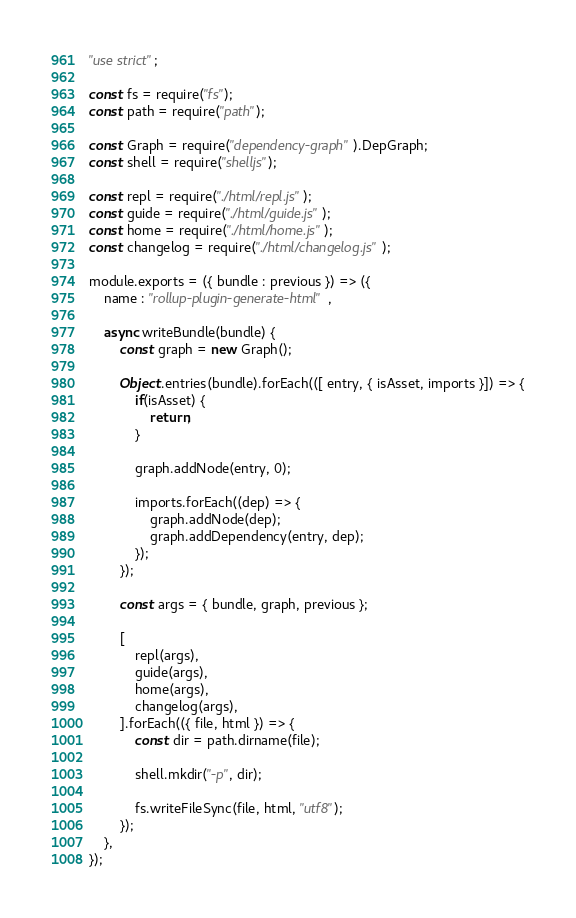Convert code to text. <code><loc_0><loc_0><loc_500><loc_500><_JavaScript_>"use strict";

const fs = require("fs");
const path = require("path");

const Graph = require("dependency-graph").DepGraph;
const shell = require("shelljs");

const repl = require("./html/repl.js");
const guide = require("./html/guide.js");
const home = require("./html/home.js");
const changelog = require("./html/changelog.js");

module.exports = ({ bundle : previous }) => ({
    name : "rollup-plugin-generate-html",

    async writeBundle(bundle) {
        const graph = new Graph();

        Object.entries(bundle).forEach(([ entry, { isAsset, imports }]) => {
            if(isAsset) {
                return;
            }

            graph.addNode(entry, 0);

            imports.forEach((dep) => {
                graph.addNode(dep);
                graph.addDependency(entry, dep);
            });
        });

        const args = { bundle, graph, previous };

        [
            repl(args),
            guide(args),
            home(args),
            changelog(args),
        ].forEach(({ file, html }) => {
            const dir = path.dirname(file);

            shell.mkdir("-p", dir);

            fs.writeFileSync(file, html, "utf8");
        });
    },
});
</code> 